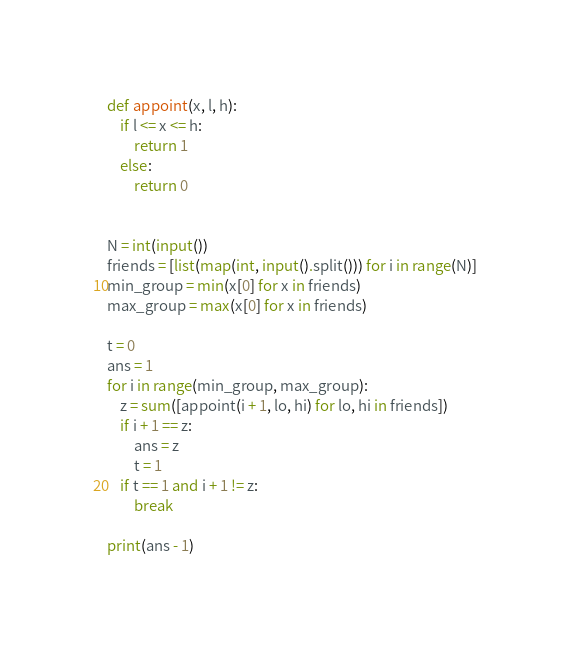Convert code to text. <code><loc_0><loc_0><loc_500><loc_500><_Python_>def appoint(x, l, h):
    if l <= x <= h:
        return 1
    else:
        return 0


N = int(input())
friends = [list(map(int, input().split())) for i in range(N)]
min_group = min(x[0] for x in friends)
max_group = max(x[0] for x in friends)

t = 0
ans = 1
for i in range(min_group, max_group):
    z = sum([appoint(i + 1, lo, hi) for lo, hi in friends])
    if i + 1 == z:
        ans = z
        t = 1
    if t == 1 and i + 1 != z:
        break

print(ans - 1)</code> 